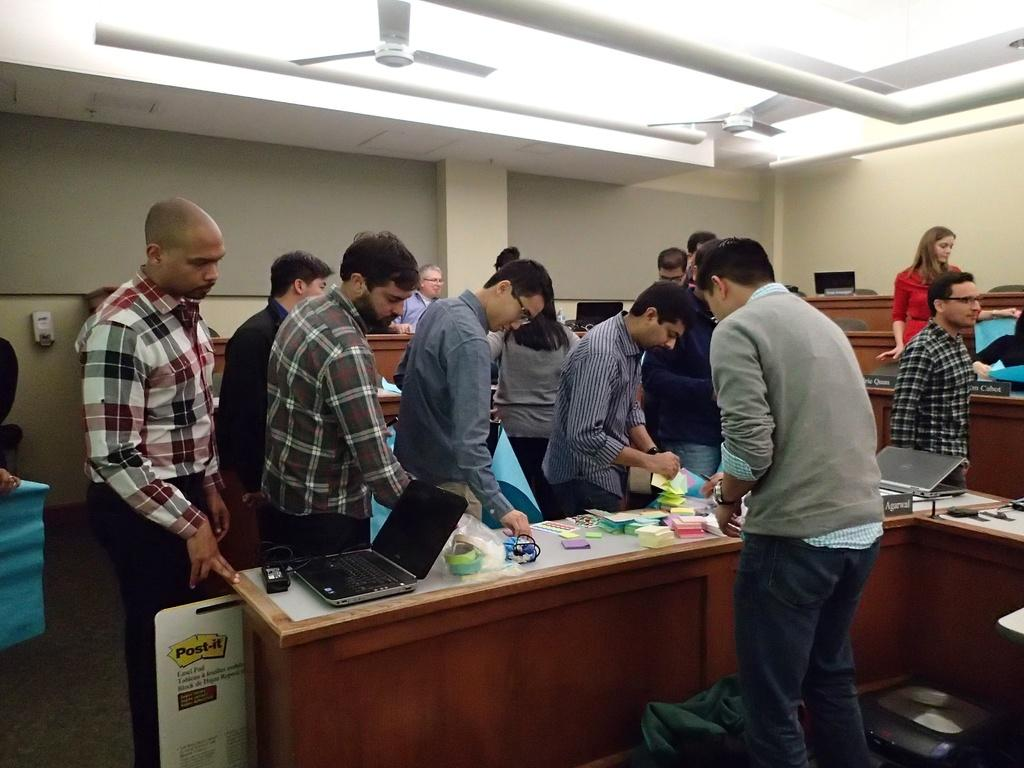How many men are in the image? There are several men in the image. What are the men doing in the image? The men are standing in a line. What is located behind the men in the image? The men are in front of a table. What can be seen on the table in the image? There is a laptop and accessories on the table. What type of setting is depicted in the image? The setting appears to be an office room. What type of bird can be seen flying in the office room in the image? There is no bird visible in the image; it depicts men standing in front of a table in an office room. 